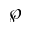Convert formula to latex. <formula><loc_0><loc_0><loc_500><loc_500>\wp</formula> 